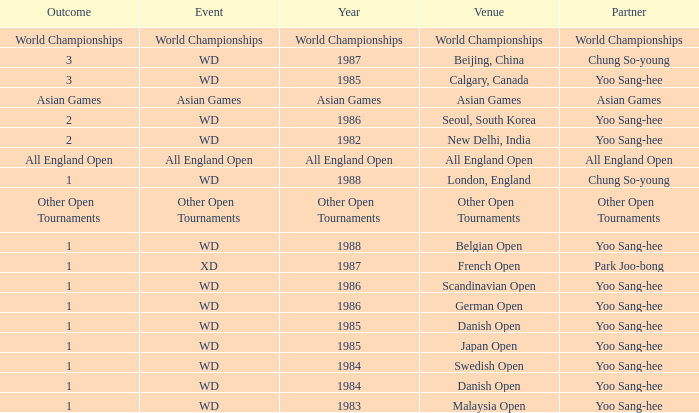What transpired at the danish open in 1985? 1.0. 